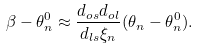<formula> <loc_0><loc_0><loc_500><loc_500>\beta - \theta ^ { 0 } _ { n } \approx \frac { d _ { o s } d _ { o l } } { d _ { l s } \xi _ { n } } ( \theta _ { n } - \theta ^ { 0 } _ { n } ) .</formula> 